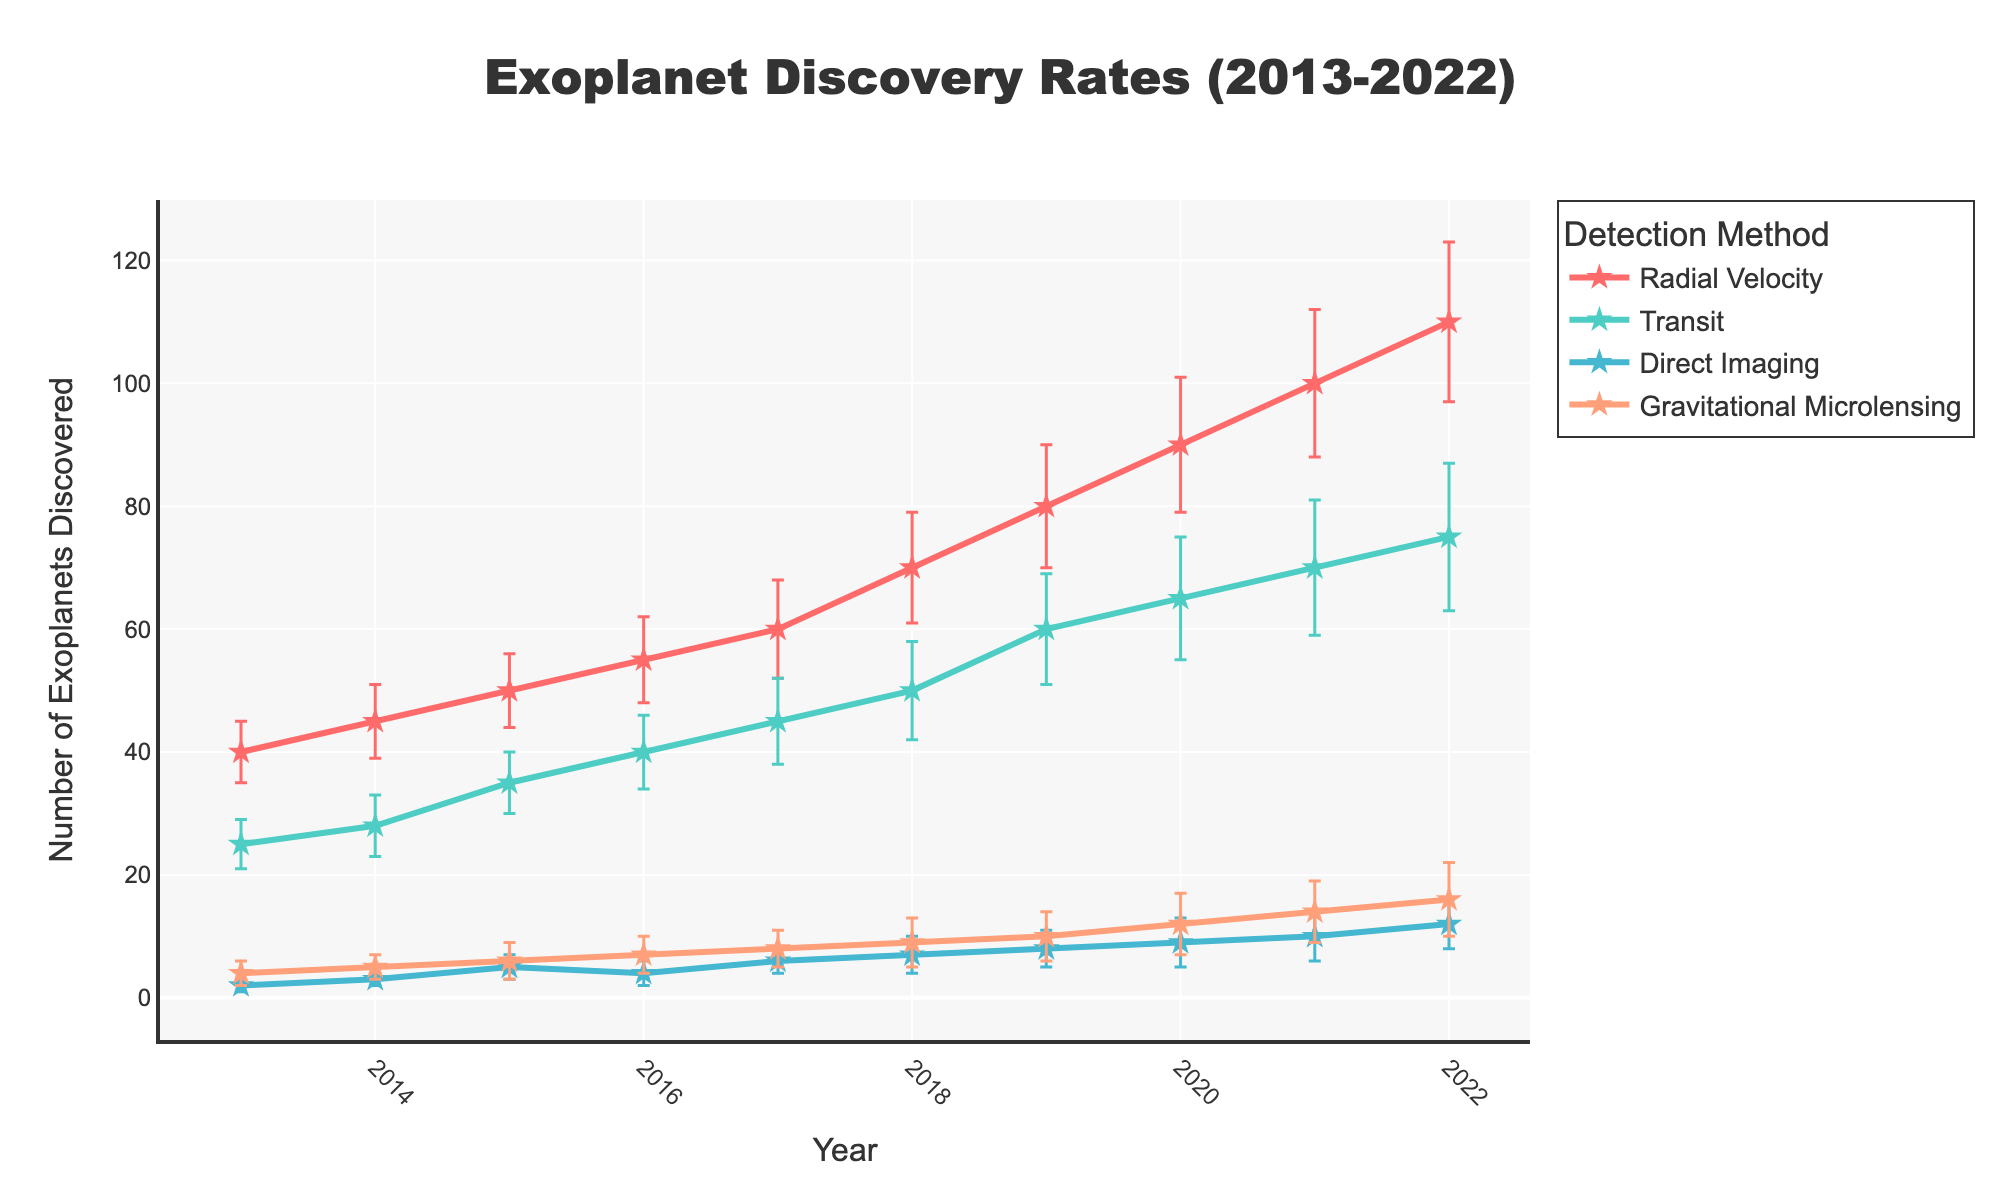What is the general trend of the exoplanet discoveries using the Radial Velocity method from 2013 to 2022? The line plot for Radial Velocity shows an increasing trend from 2013 to 2022, as the number of exoplanets discovered grows from 40 to 110.
Answer: Increasing In which year did the Transit method detect the greatest number of exoplanets? By observing the plot, the highest point for the Transit method is in 2022, where the number of exoplanets detected reaches 75.
Answer: 2022 How do the error margins for Radial Velocity and Transit methods compare in 2019? In 2019, the error margin for Radial Velocity is 10, while for the Transit method, it is 9. The error margin for Radial Velocity is slightly higher.
Answer: Radial Velocity has higher error margin What is the total number of exoplanets discovered by the Direct Imaging method from 2013 to 2022? Summing the data points for Direct Imaging method: 2 + 3 + 5 + 4 + 6 + 7 + 8 + 9 + 10 + 12 = 66.
Answer: 66 Which detection method observed the least number of exoplanets in 2016, and how many did it observe? By looking at the 2016 data points, the Direct Imaging method discovered the least number, which is 4 exoplanets.
Answer: Direct Imaging, 4 Compare the growth rate of exoplanet discoveries between the Radial Velocity and Gravitational Microlensing methods from 2013 to 2022. Radial Velocity increases from 40 to 110, a growth of 70 exoplanets over 10 years. Gravitational Microlensing increases from 4 to 16, a growth of 12 exoplanets over 10 years. The growth rate for Radial Velocity is significantly higher.
Answer: Radial Velocity has a higher growth rate What are the error bars for the Gravitational Microlensing method in 2020? The error bar for Gravitational Microlensing in 2020 is shown as 5.
Answer: 5 Which detection method has the largest error margin in any given year, and in which year does this occur? The largest error margin observed is for Radial Velocity in 2022, with an error of 13.
Answer: Radial Velocity, 2022 What is the average number of exoplanets discovered by the Transit method from 2013 to 2022? Summing the data points for the Transit method: 25 + 28 + 35 + 40 + 45 + 50 + 60 + 65 + 70 + 75 = 493. Dividing by the 10 years, the average is 493 / 10 = 49.3.
Answer: 49.3 